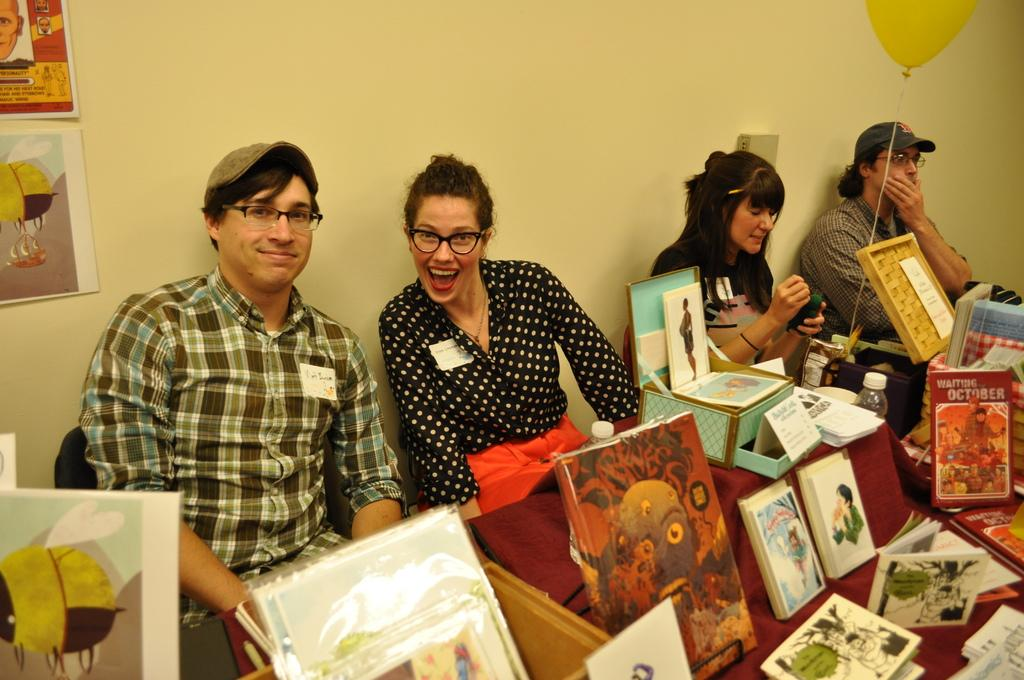How many people are present in the image? There are people in the image, but the exact number cannot be determined from the provided facts. What is the woman holding in the image? The woman is holding an object in the image. What type of items can be seen in the image besides people? There are bottles, books, papers, a thread with a balloon, and objects on a table in the image. What can be seen on the wall in the background of the image? There are posts on the wall in the background of the image. What time is displayed on the clock in the image? There is no clock present in the image, so it is not possible to determine the time. 